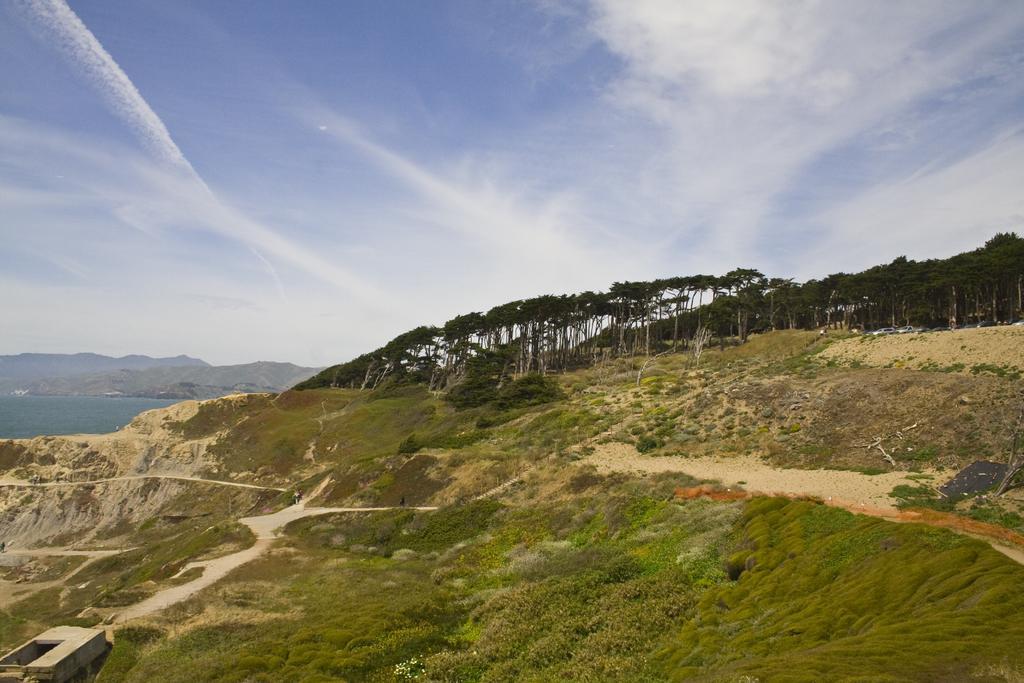In one or two sentences, can you explain what this image depicts? In this picture I can see grass, plants and trees. On the left side I can see water, mountain and the sky in the background. 